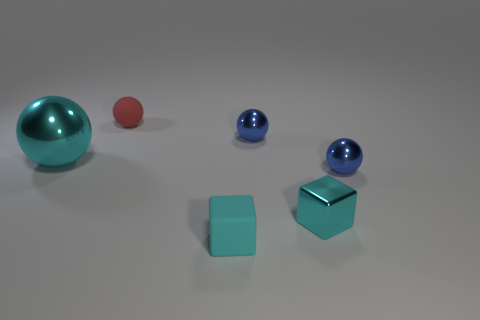Add 2 cyan metallic spheres. How many objects exist? 8 Subtract all blocks. How many objects are left? 4 Add 3 metallic cubes. How many metallic cubes are left? 4 Add 6 red matte balls. How many red matte balls exist? 7 Subtract 0 yellow balls. How many objects are left? 6 Subtract all blue things. Subtract all tiny metal things. How many objects are left? 1 